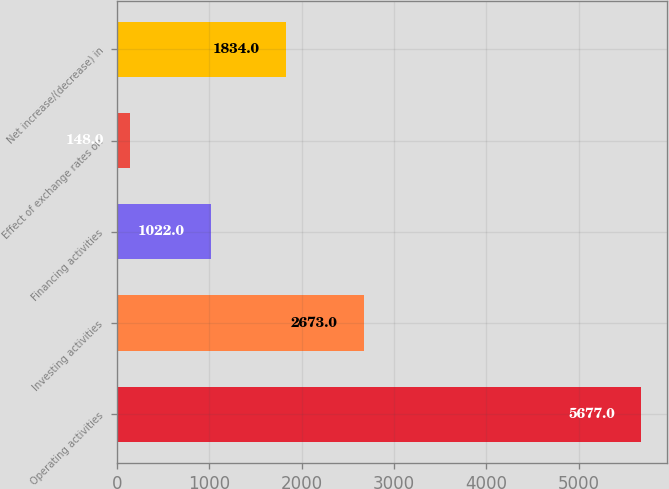Convert chart. <chart><loc_0><loc_0><loc_500><loc_500><bar_chart><fcel>Operating activities<fcel>Investing activities<fcel>Financing activities<fcel>Effect of exchange rates on<fcel>Net increase/(decrease) in<nl><fcel>5677<fcel>2673<fcel>1022<fcel>148<fcel>1834<nl></chart> 